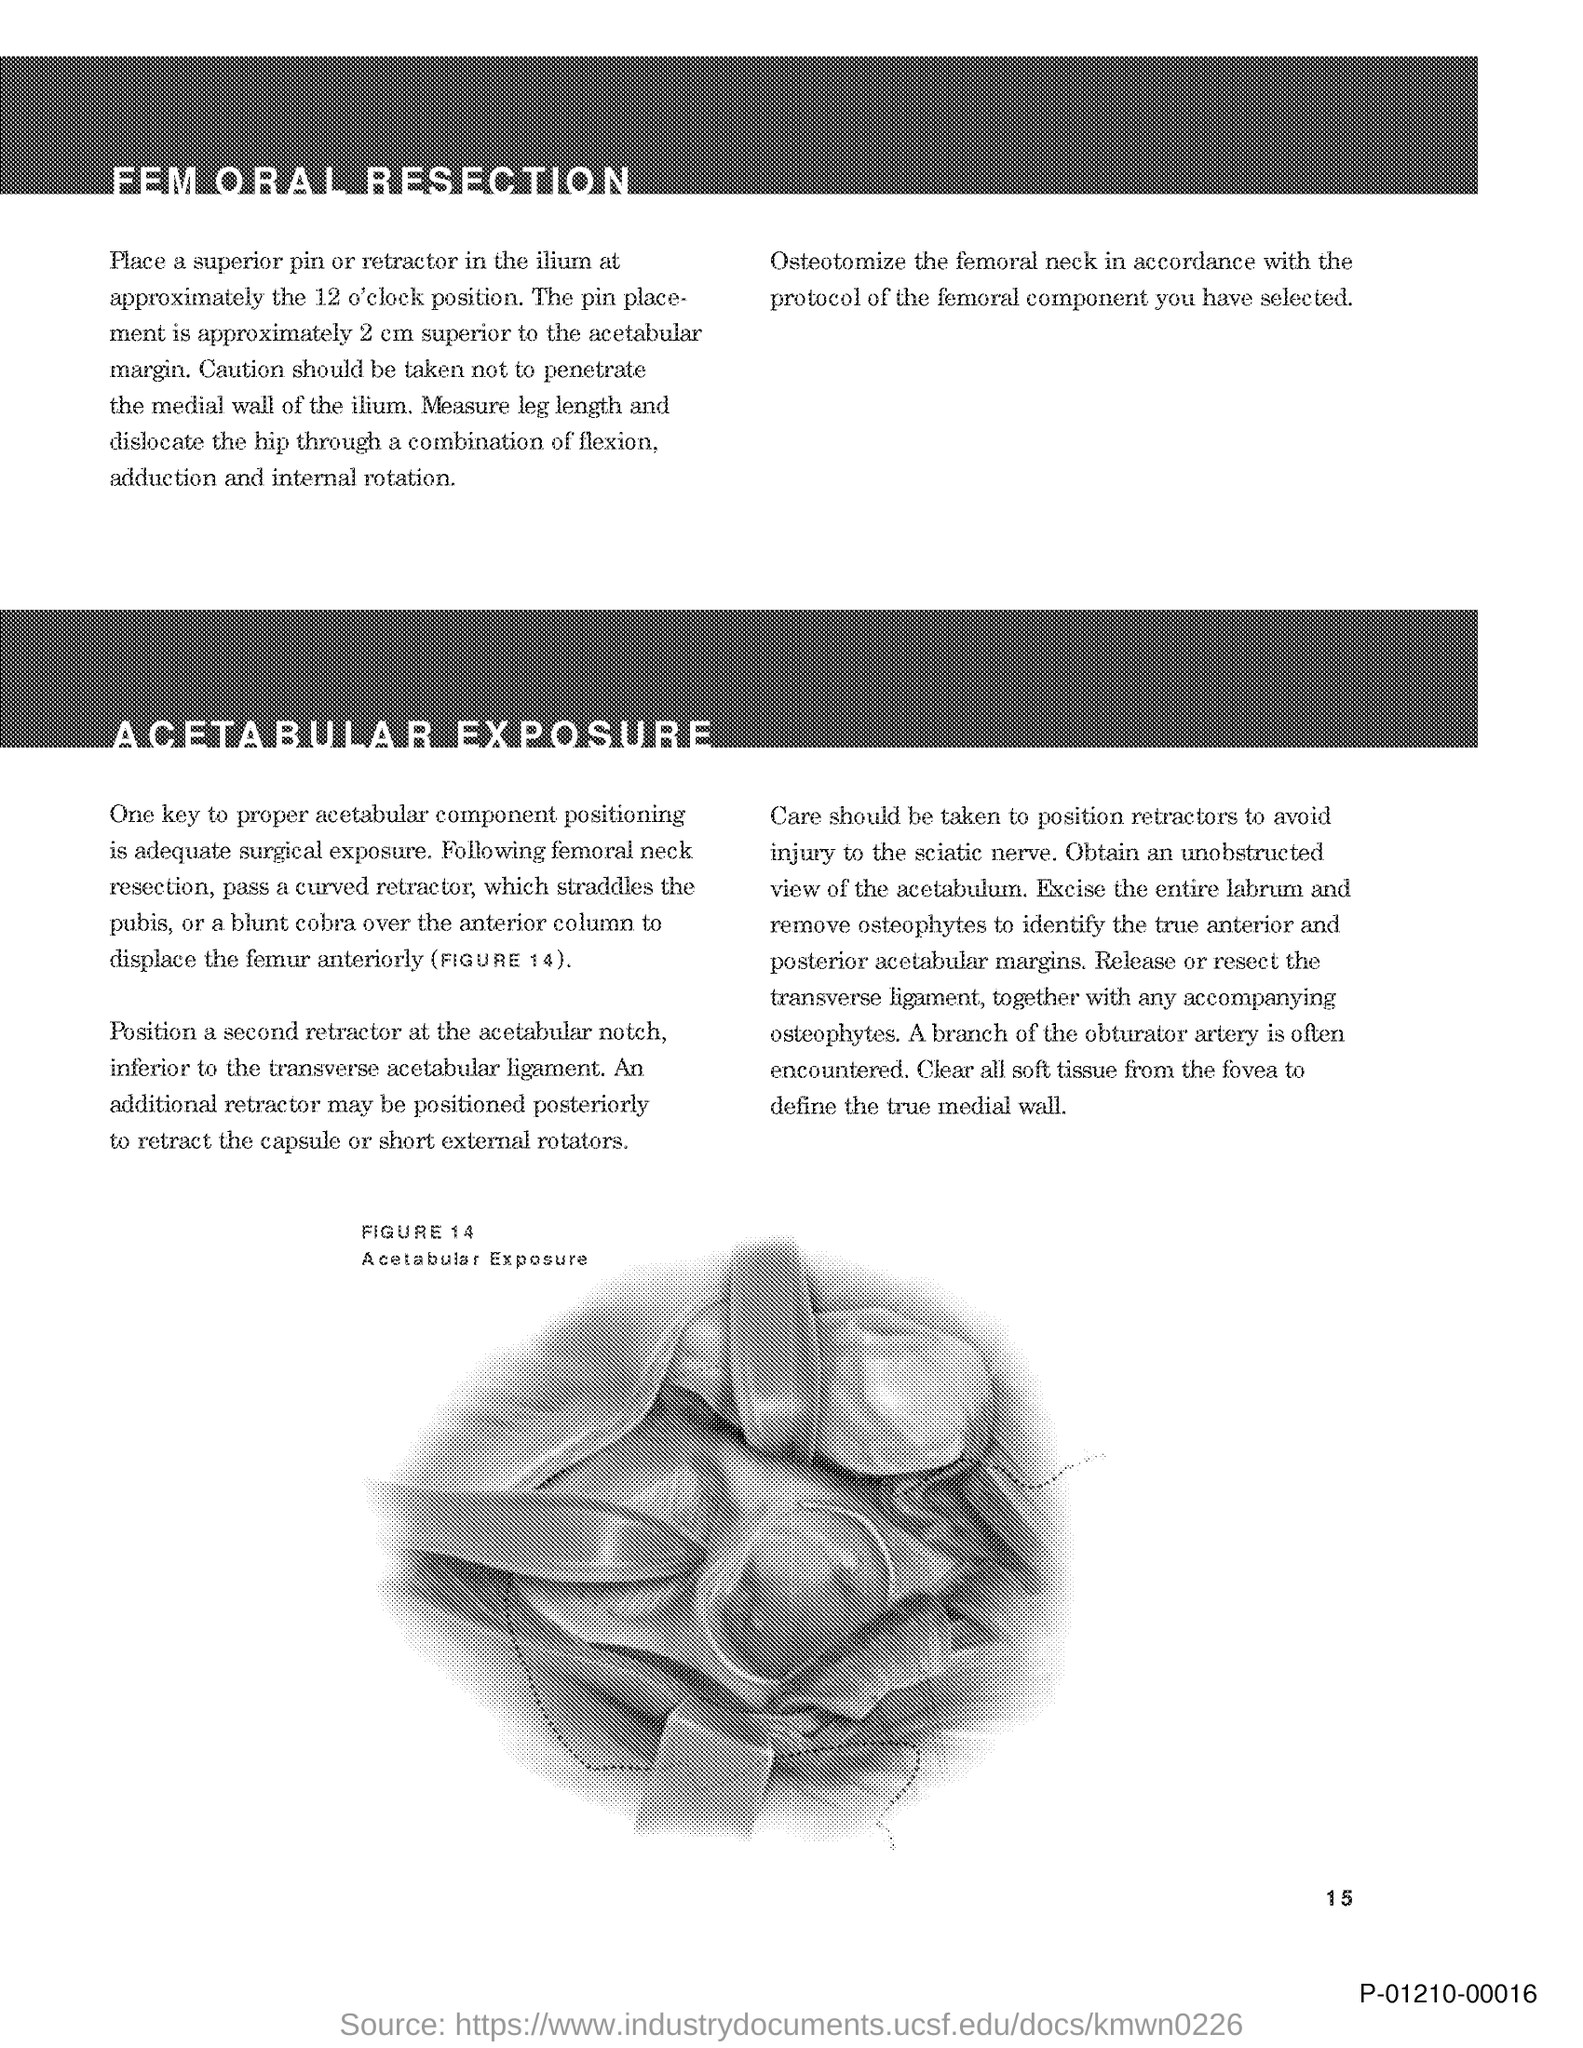What is the page no mentioned in this document?
Offer a very short reply. 15. What does FIGURE 14 in this document represent?
Your answer should be compact. Acetabular Exposure. 